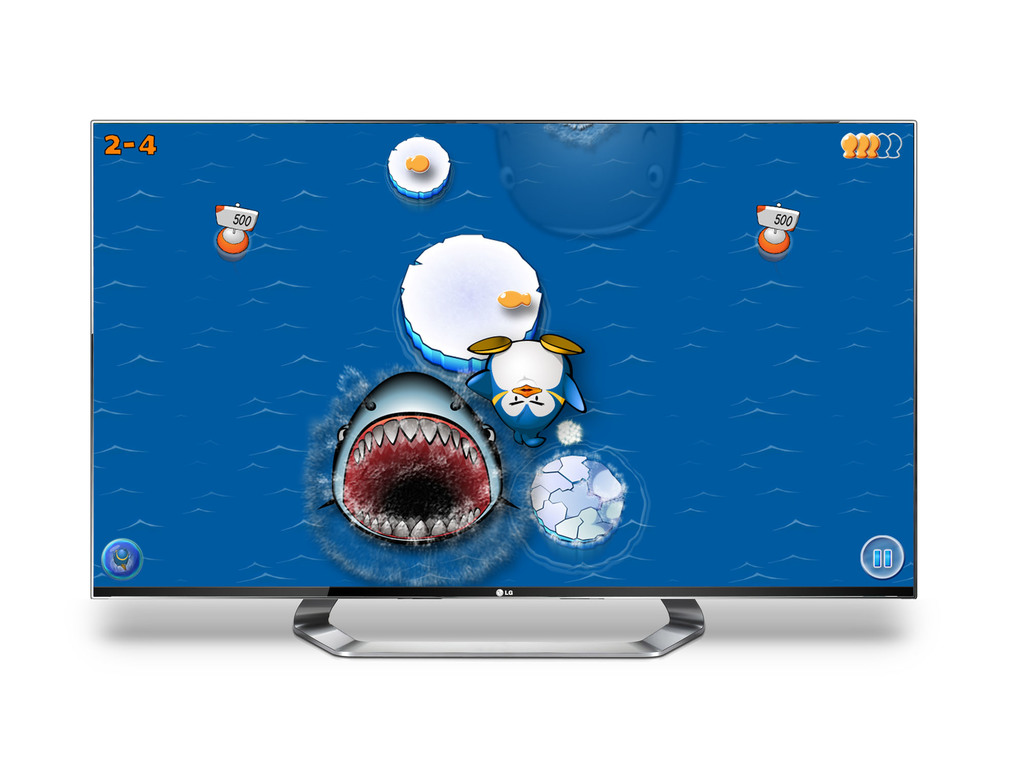Can you describe one specific game element visible in the image? One notable game element shown is a large, menacing animated shark with sharp teeth, likely serving as a challenging antagonist in the game's narrative. 